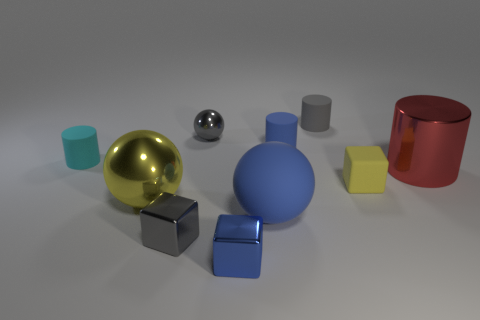Subtract all spheres. How many objects are left? 7 Add 4 red things. How many red things are left? 5 Add 1 big brown metallic objects. How many big brown metallic objects exist? 1 Subtract 0 cyan spheres. How many objects are left? 10 Subtract all blue cylinders. Subtract all small gray shiny objects. How many objects are left? 7 